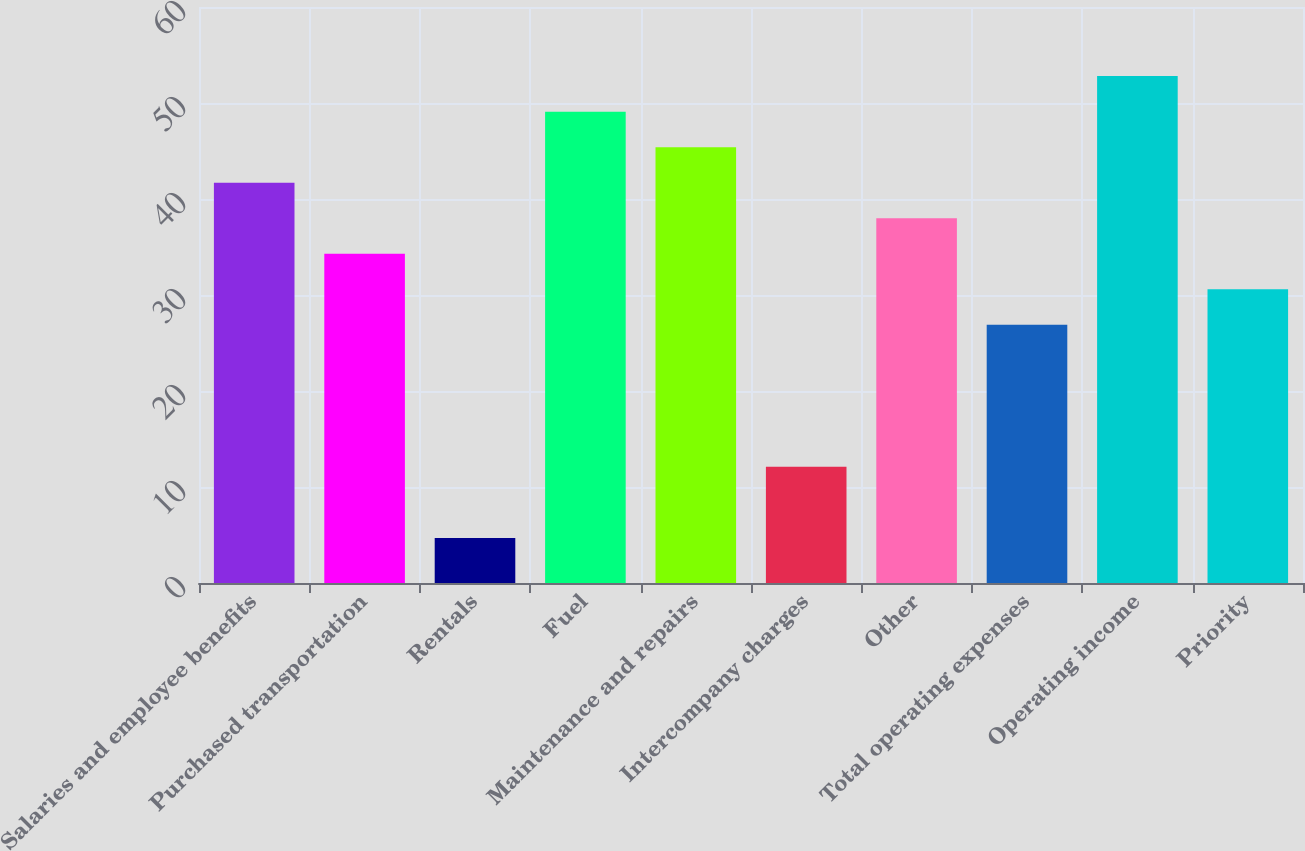Convert chart. <chart><loc_0><loc_0><loc_500><loc_500><bar_chart><fcel>Salaries and employee benefits<fcel>Purchased transportation<fcel>Rentals<fcel>Fuel<fcel>Maintenance and repairs<fcel>Intercompany charges<fcel>Other<fcel>Total operating expenses<fcel>Operating income<fcel>Priority<nl><fcel>41.7<fcel>34.3<fcel>4.7<fcel>49.1<fcel>45.4<fcel>12.1<fcel>38<fcel>26.9<fcel>52.8<fcel>30.6<nl></chart> 